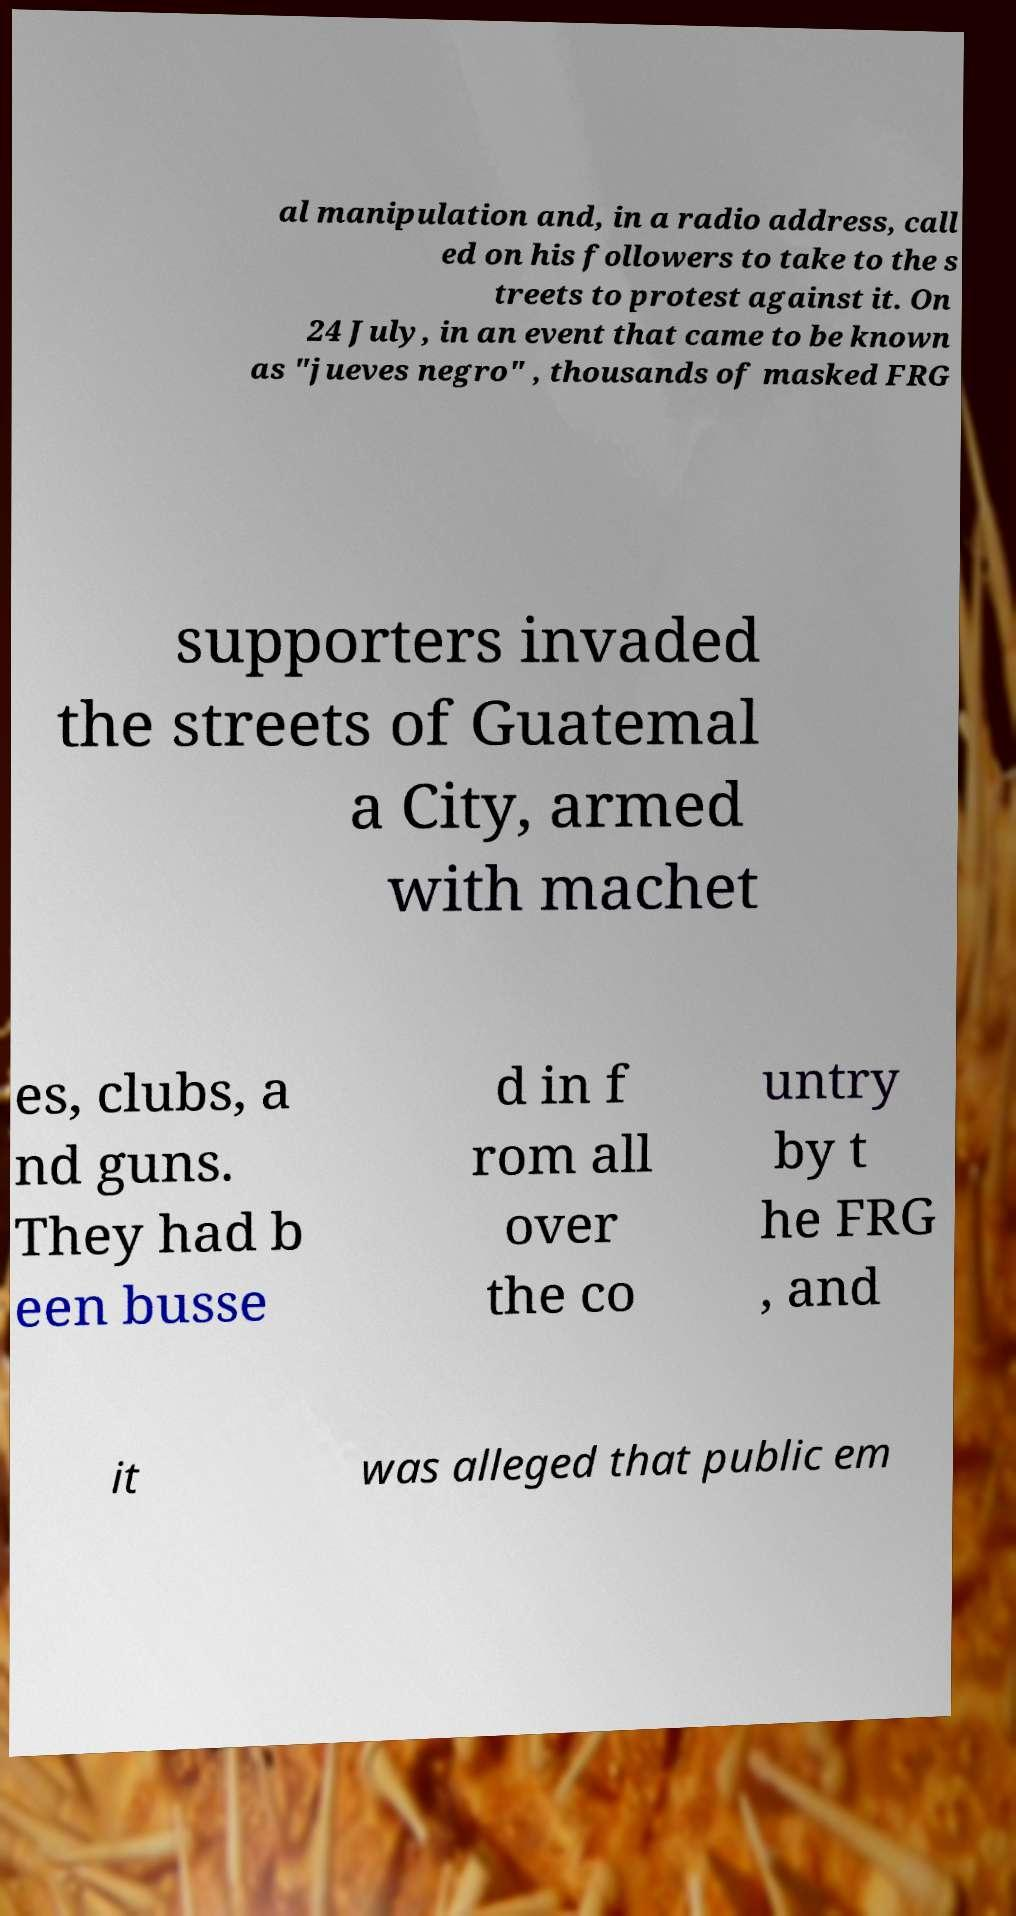Please identify and transcribe the text found in this image. al manipulation and, in a radio address, call ed on his followers to take to the s treets to protest against it. On 24 July, in an event that came to be known as "jueves negro" , thousands of masked FRG supporters invaded the streets of Guatemal a City, armed with machet es, clubs, a nd guns. They had b een busse d in f rom all over the co untry by t he FRG , and it was alleged that public em 